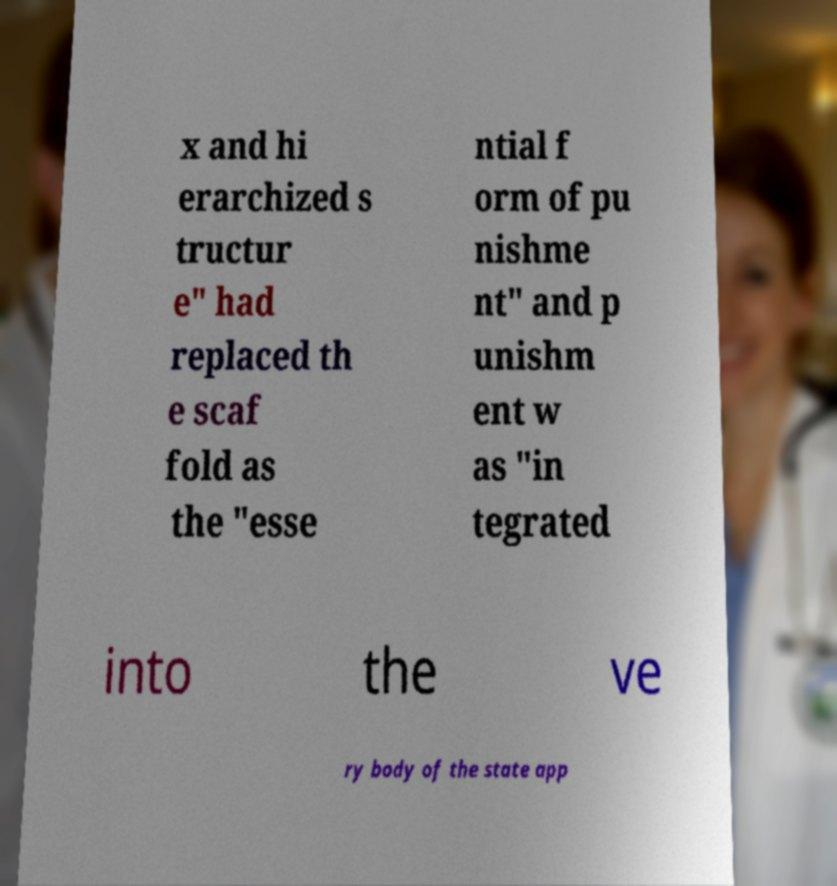Can you accurately transcribe the text from the provided image for me? x and hi erarchized s tructur e" had replaced th e scaf fold as the "esse ntial f orm of pu nishme nt" and p unishm ent w as "in tegrated into the ve ry body of the state app 